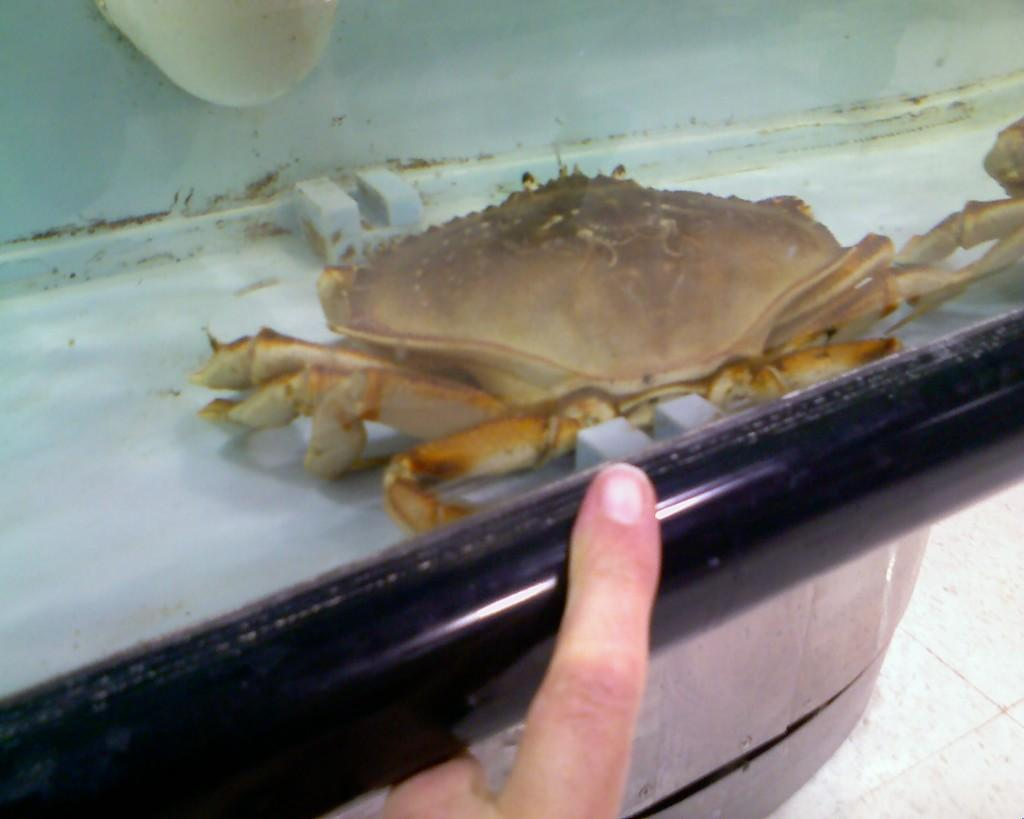What type of animal is in the image? There is a crab in the image. What is the color of the surface the crab is on? The crab is on a white surface. Whose fingers are visible in the image? The fingers in the image belong to someone who is likely interacting with the crab. What type of milk is being poured from the guitar in the image? There is no guitar or milk present in the image; it features a crab on a white surface with fingers visible. 